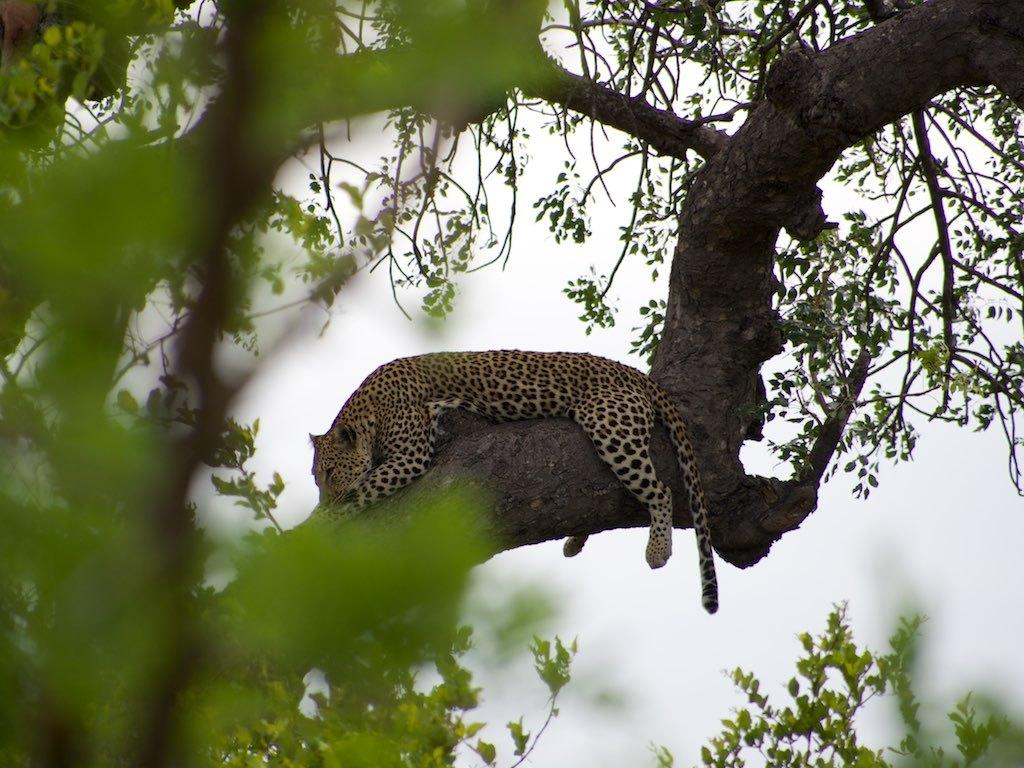What type of animal can be seen in the image? There is an animal in the image, but its specific type cannot be determined from the provided facts. Where is the animal located in the image? The animal is on a tree in the image. What can be seen in the background of the image? The sky is visible in the image. What type of juice is being served in the image? There is no juice present in the image; it features an animal on a tree with a visible sky. 